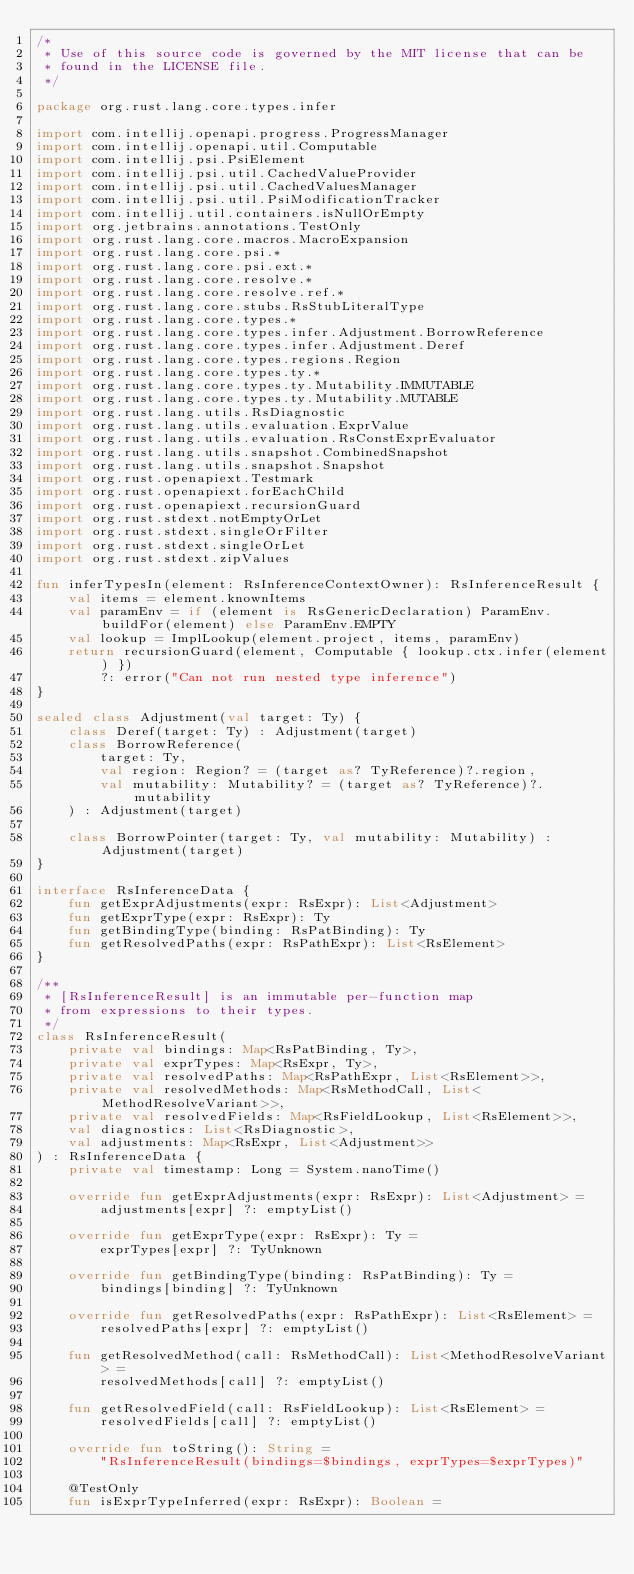<code> <loc_0><loc_0><loc_500><loc_500><_Kotlin_>/*
 * Use of this source code is governed by the MIT license that can be
 * found in the LICENSE file.
 */

package org.rust.lang.core.types.infer

import com.intellij.openapi.progress.ProgressManager
import com.intellij.openapi.util.Computable
import com.intellij.psi.PsiElement
import com.intellij.psi.util.CachedValueProvider
import com.intellij.psi.util.CachedValuesManager
import com.intellij.psi.util.PsiModificationTracker
import com.intellij.util.containers.isNullOrEmpty
import org.jetbrains.annotations.TestOnly
import org.rust.lang.core.macros.MacroExpansion
import org.rust.lang.core.psi.*
import org.rust.lang.core.psi.ext.*
import org.rust.lang.core.resolve.*
import org.rust.lang.core.resolve.ref.*
import org.rust.lang.core.stubs.RsStubLiteralType
import org.rust.lang.core.types.*
import org.rust.lang.core.types.infer.Adjustment.BorrowReference
import org.rust.lang.core.types.infer.Adjustment.Deref
import org.rust.lang.core.types.regions.Region
import org.rust.lang.core.types.ty.*
import org.rust.lang.core.types.ty.Mutability.IMMUTABLE
import org.rust.lang.core.types.ty.Mutability.MUTABLE
import org.rust.lang.utils.RsDiagnostic
import org.rust.lang.utils.evaluation.ExprValue
import org.rust.lang.utils.evaluation.RsConstExprEvaluator
import org.rust.lang.utils.snapshot.CombinedSnapshot
import org.rust.lang.utils.snapshot.Snapshot
import org.rust.openapiext.Testmark
import org.rust.openapiext.forEachChild
import org.rust.openapiext.recursionGuard
import org.rust.stdext.notEmptyOrLet
import org.rust.stdext.singleOrFilter
import org.rust.stdext.singleOrLet
import org.rust.stdext.zipValues

fun inferTypesIn(element: RsInferenceContextOwner): RsInferenceResult {
    val items = element.knownItems
    val paramEnv = if (element is RsGenericDeclaration) ParamEnv.buildFor(element) else ParamEnv.EMPTY
    val lookup = ImplLookup(element.project, items, paramEnv)
    return recursionGuard(element, Computable { lookup.ctx.infer(element) })
        ?: error("Can not run nested type inference")
}

sealed class Adjustment(val target: Ty) {
    class Deref(target: Ty) : Adjustment(target)
    class BorrowReference(
        target: Ty,
        val region: Region? = (target as? TyReference)?.region,
        val mutability: Mutability? = (target as? TyReference)?.mutability
    ) : Adjustment(target)

    class BorrowPointer(target: Ty, val mutability: Mutability) : Adjustment(target)
}

interface RsInferenceData {
    fun getExprAdjustments(expr: RsExpr): List<Adjustment>
    fun getExprType(expr: RsExpr): Ty
    fun getBindingType(binding: RsPatBinding): Ty
    fun getResolvedPaths(expr: RsPathExpr): List<RsElement>
}

/**
 * [RsInferenceResult] is an immutable per-function map
 * from expressions to their types.
 */
class RsInferenceResult(
    private val bindings: Map<RsPatBinding, Ty>,
    private val exprTypes: Map<RsExpr, Ty>,
    private val resolvedPaths: Map<RsPathExpr, List<RsElement>>,
    private val resolvedMethods: Map<RsMethodCall, List<MethodResolveVariant>>,
    private val resolvedFields: Map<RsFieldLookup, List<RsElement>>,
    val diagnostics: List<RsDiagnostic>,
    val adjustments: Map<RsExpr, List<Adjustment>>
) : RsInferenceData {
    private val timestamp: Long = System.nanoTime()

    override fun getExprAdjustments(expr: RsExpr): List<Adjustment> =
        adjustments[expr] ?: emptyList()

    override fun getExprType(expr: RsExpr): Ty =
        exprTypes[expr] ?: TyUnknown

    override fun getBindingType(binding: RsPatBinding): Ty =
        bindings[binding] ?: TyUnknown

    override fun getResolvedPaths(expr: RsPathExpr): List<RsElement> =
        resolvedPaths[expr] ?: emptyList()

    fun getResolvedMethod(call: RsMethodCall): List<MethodResolveVariant> =
        resolvedMethods[call] ?: emptyList()

    fun getResolvedField(call: RsFieldLookup): List<RsElement> =
        resolvedFields[call] ?: emptyList()

    override fun toString(): String =
        "RsInferenceResult(bindings=$bindings, exprTypes=$exprTypes)"

    @TestOnly
    fun isExprTypeInferred(expr: RsExpr): Boolean =</code> 